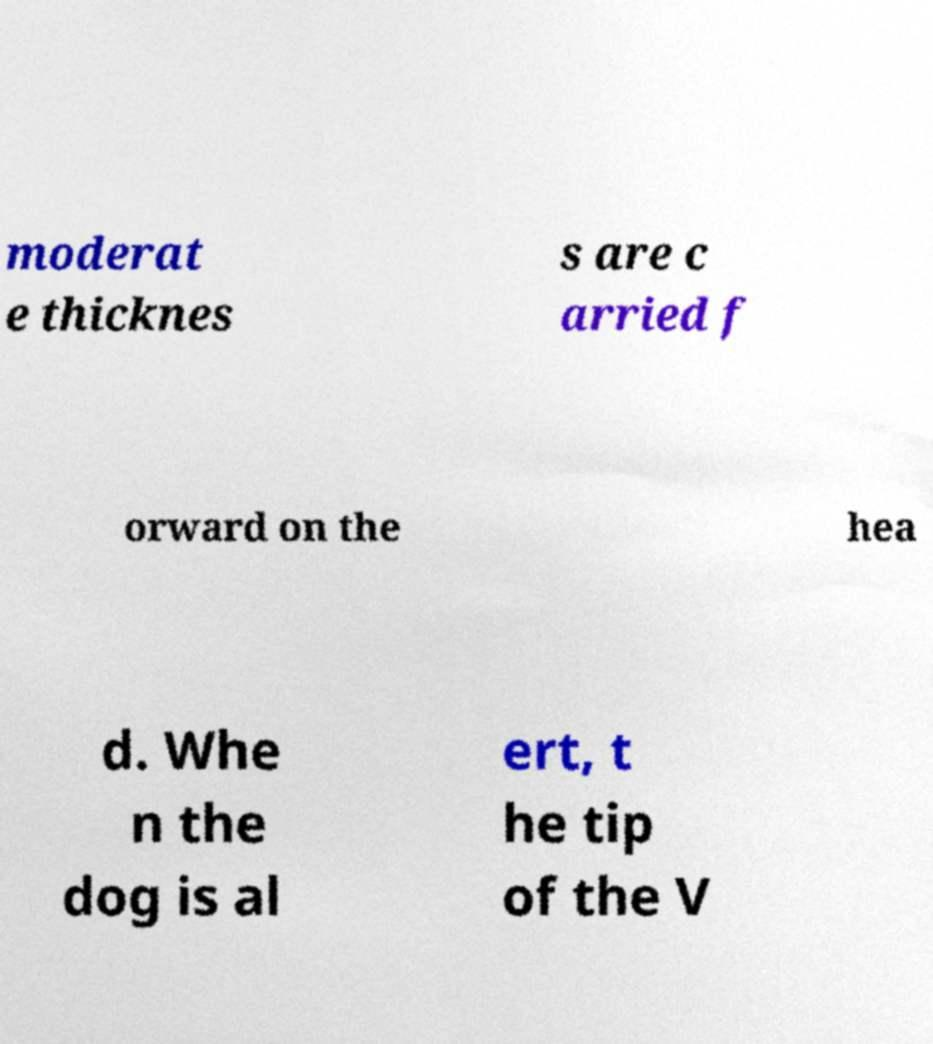There's text embedded in this image that I need extracted. Can you transcribe it verbatim? moderat e thicknes s are c arried f orward on the hea d. Whe n the dog is al ert, t he tip of the V 